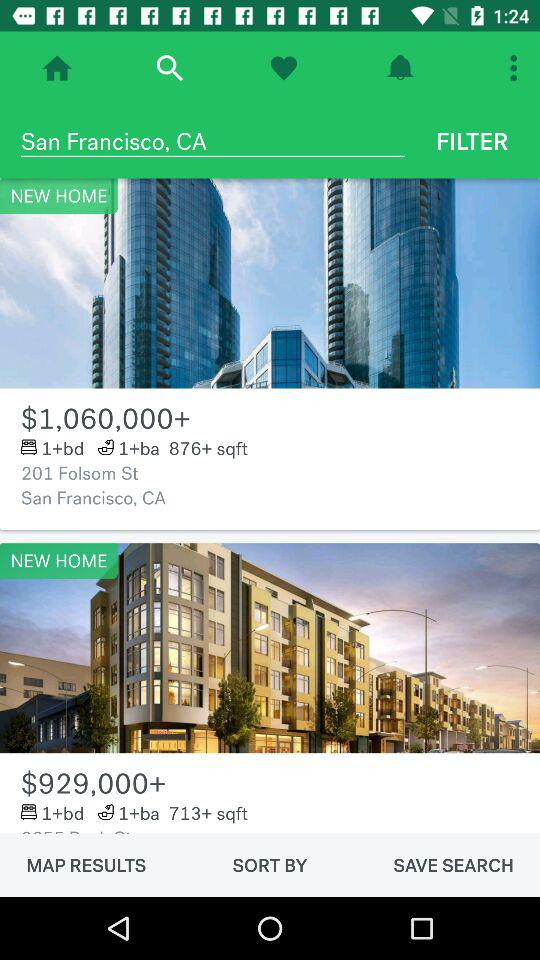What location is selected? The selected location is San Francisco, CA. 